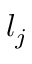<formula> <loc_0><loc_0><loc_500><loc_500>l _ { j }</formula> 